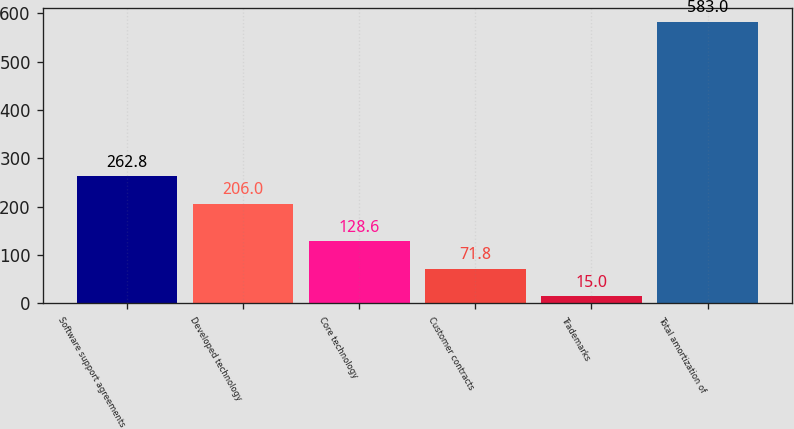Convert chart. <chart><loc_0><loc_0><loc_500><loc_500><bar_chart><fcel>Software support agreements<fcel>Developed technology<fcel>Core technology<fcel>Customer contracts<fcel>Trademarks<fcel>Total amortization of<nl><fcel>262.8<fcel>206<fcel>128.6<fcel>71.8<fcel>15<fcel>583<nl></chart> 